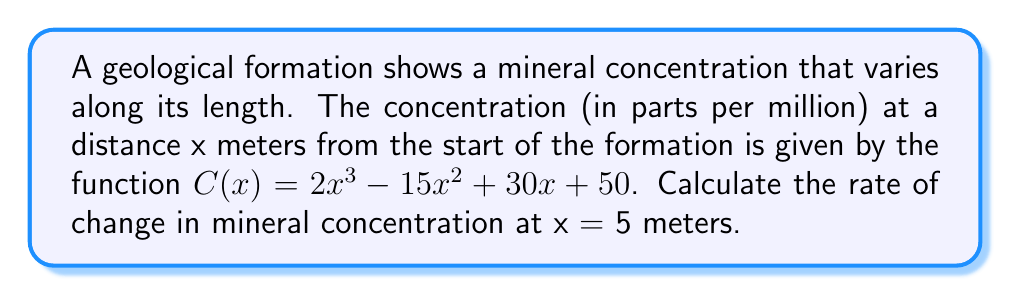Provide a solution to this math problem. To find the rate of change in mineral concentration at a specific point, we need to calculate the derivative of the concentration function C(x) and then evaluate it at the given point.

Step 1: Find the derivative of C(x)
$$C(x) = 2x^3 - 15x^2 + 30x + 50$$
$$C'(x) = 6x^2 - 30x + 30$$

Step 2: Evaluate C'(x) at x = 5
$$C'(5) = 6(5)^2 - 30(5) + 30$$
$$C'(5) = 6(25) - 150 + 30$$
$$C'(5) = 150 - 150 + 30$$
$$C'(5) = 30$$

The rate of change at x = 5 meters is 30 parts per million per meter.
Answer: 30 ppm/m 